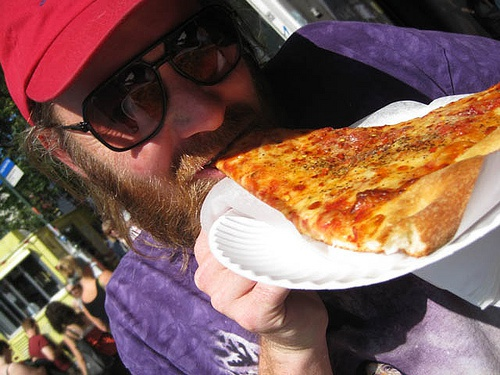Describe the objects in this image and their specific colors. I can see people in black, brown, white, maroon, and purple tones, pizza in brown, red, and orange tones, people in brown, black, gray, and maroon tones, people in brown, black, maroon, and tan tones, and people in brown, black, and maroon tones in this image. 